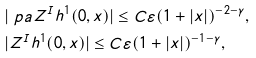Convert formula to latex. <formula><loc_0><loc_0><loc_500><loc_500>& | \ p a Z ^ { I } h ^ { 1 } ( 0 , x ) | \leq C \varepsilon ( 1 + | x | ) ^ { - 2 - \gamma } , \\ & | Z ^ { I } h ^ { 1 } ( 0 , x ) | \leq C \varepsilon ( 1 + | x | ) ^ { - 1 - \gamma } ,</formula> 